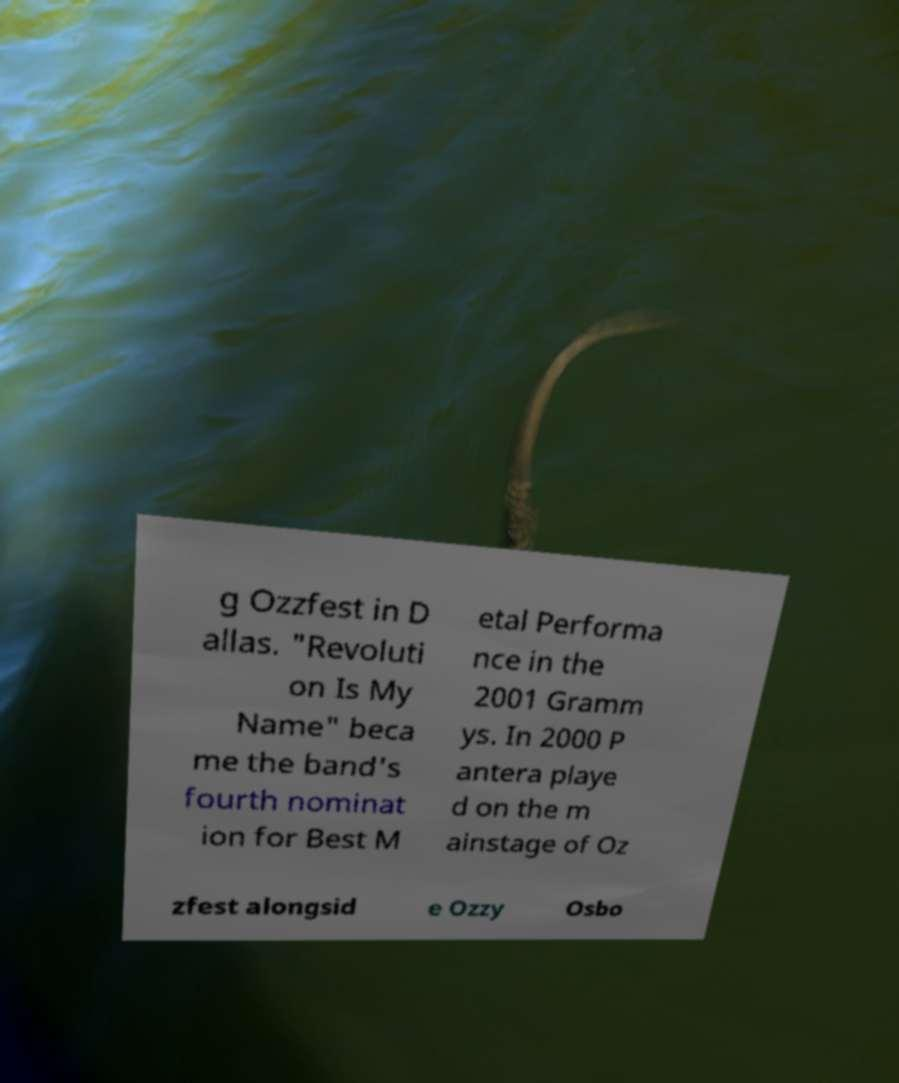Please identify and transcribe the text found in this image. g Ozzfest in D allas. "Revoluti on Is My Name" beca me the band's fourth nominat ion for Best M etal Performa nce in the 2001 Gramm ys. In 2000 P antera playe d on the m ainstage of Oz zfest alongsid e Ozzy Osbo 